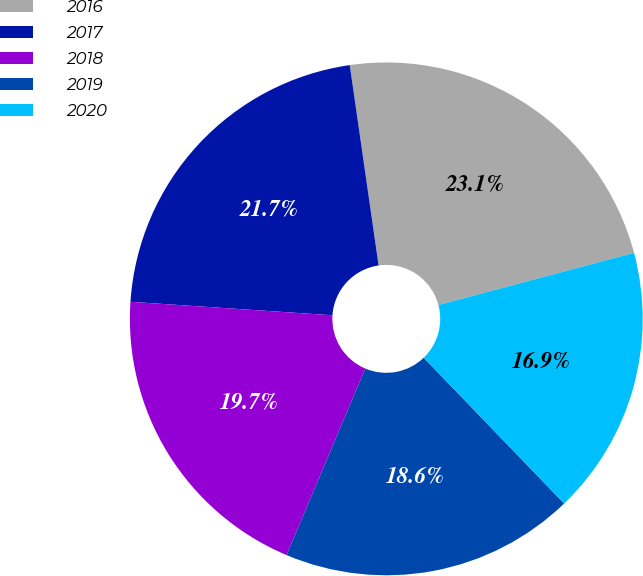Convert chart. <chart><loc_0><loc_0><loc_500><loc_500><pie_chart><fcel>2016<fcel>2017<fcel>2018<fcel>2019<fcel>2020<nl><fcel>23.13%<fcel>21.66%<fcel>19.7%<fcel>18.56%<fcel>16.94%<nl></chart> 